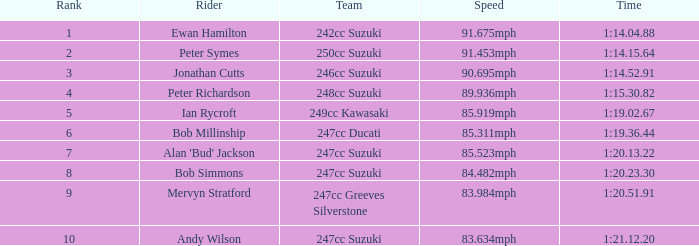64? 91.453mph. 